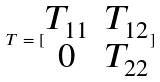<formula> <loc_0><loc_0><loc_500><loc_500>T = [ \begin{matrix} T _ { 1 1 } & T _ { 1 2 } \\ 0 & T _ { 2 2 } \end{matrix} ]</formula> 